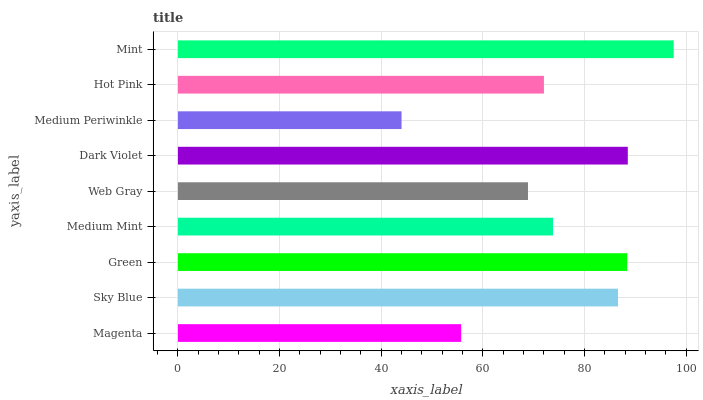Is Medium Periwinkle the minimum?
Answer yes or no. Yes. Is Mint the maximum?
Answer yes or no. Yes. Is Sky Blue the minimum?
Answer yes or no. No. Is Sky Blue the maximum?
Answer yes or no. No. Is Sky Blue greater than Magenta?
Answer yes or no. Yes. Is Magenta less than Sky Blue?
Answer yes or no. Yes. Is Magenta greater than Sky Blue?
Answer yes or no. No. Is Sky Blue less than Magenta?
Answer yes or no. No. Is Medium Mint the high median?
Answer yes or no. Yes. Is Medium Mint the low median?
Answer yes or no. Yes. Is Sky Blue the high median?
Answer yes or no. No. Is Mint the low median?
Answer yes or no. No. 